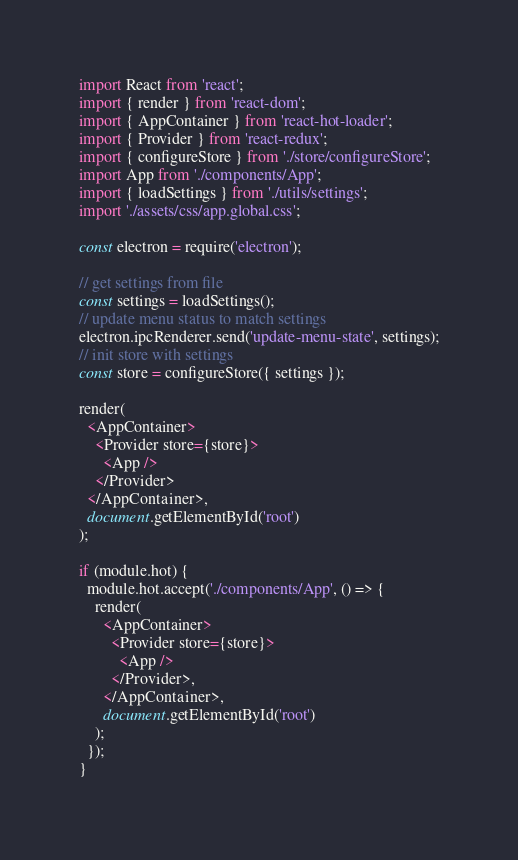<code> <loc_0><loc_0><loc_500><loc_500><_JavaScript_>import React from 'react';
import { render } from 'react-dom';
import { AppContainer } from 'react-hot-loader';
import { Provider } from 'react-redux';
import { configureStore } from './store/configureStore';
import App from './components/App';
import { loadSettings } from './utils/settings';
import './assets/css/app.global.css';

const electron = require('electron');

// get settings from file
const settings = loadSettings();
// update menu status to match settings
electron.ipcRenderer.send('update-menu-state', settings);
// init store with settings
const store = configureStore({ settings });

render(
  <AppContainer>
    <Provider store={store}>
      <App />
    </Provider>
  </AppContainer>,
  document.getElementById('root')
);

if (module.hot) {
  module.hot.accept('./components/App', () => {
    render(
      <AppContainer>
        <Provider store={store}>
          <App />
        </Provider>,
      </AppContainer>,
      document.getElementById('root')
    );
  });
}
</code> 